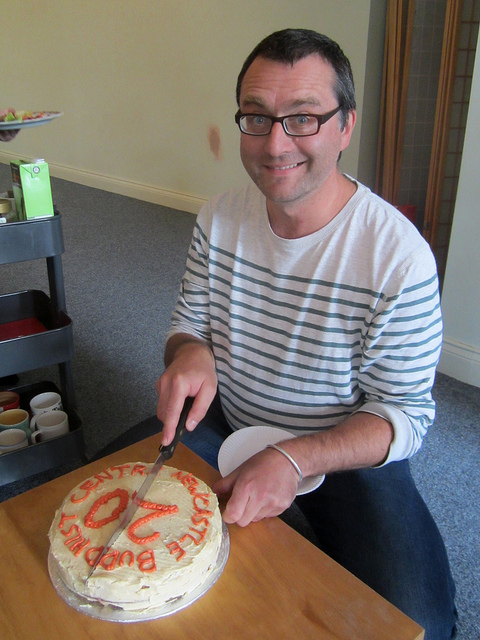<image>What holiday season is it? It's ambiguous what holiday season it is. It could be Halloween, Summer, Fall, Buddhist, Birthday, Easter or Christmas. Who is the woman in the photo? There is no woman in the photo. What fruit is on the cake? I don't know what fruit is on the cake. There might be none or it could be a strawberry, oranges, or a carrot. What holiday season is it? I don't know what holiday season it is. It could be any of Halloween, Fall, Easter, or Christmas. Who is the woman in the photo? There is no woman in the photo. What fruit is on the cake? I don't know what fruit is on the cake. It is not clear from the image. 